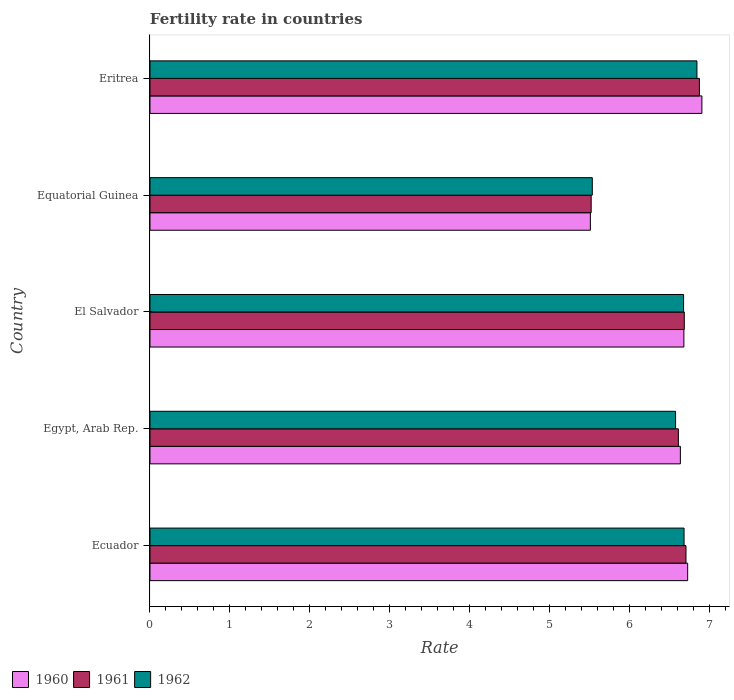How many different coloured bars are there?
Your response must be concise. 3. How many groups of bars are there?
Make the answer very short. 5. Are the number of bars on each tick of the Y-axis equal?
Keep it short and to the point. Yes. What is the label of the 4th group of bars from the top?
Give a very brief answer. Egypt, Arab Rep. What is the fertility rate in 1960 in Egypt, Arab Rep.?
Ensure brevity in your answer.  6.63. Across all countries, what is the maximum fertility rate in 1961?
Ensure brevity in your answer.  6.87. Across all countries, what is the minimum fertility rate in 1961?
Your response must be concise. 5.51. In which country was the fertility rate in 1960 maximum?
Give a very brief answer. Eritrea. In which country was the fertility rate in 1960 minimum?
Provide a succinct answer. Equatorial Guinea. What is the total fertility rate in 1960 in the graph?
Your answer should be compact. 32.43. What is the difference between the fertility rate in 1961 in El Salvador and that in Eritrea?
Your answer should be compact. -0.19. What is the difference between the fertility rate in 1960 in Eritrea and the fertility rate in 1962 in Egypt, Arab Rep.?
Give a very brief answer. 0.33. What is the average fertility rate in 1962 per country?
Offer a terse response. 6.46. What is the difference between the fertility rate in 1961 and fertility rate in 1962 in Eritrea?
Your answer should be very brief. 0.03. In how many countries, is the fertility rate in 1961 greater than 2.6 ?
Provide a succinct answer. 5. What is the ratio of the fertility rate in 1960 in Ecuador to that in Eritrea?
Provide a succinct answer. 0.97. Is the fertility rate in 1961 in Egypt, Arab Rep. less than that in Equatorial Guinea?
Ensure brevity in your answer.  No. What is the difference between the highest and the second highest fertility rate in 1960?
Provide a short and direct response. 0.18. What is the difference between the highest and the lowest fertility rate in 1961?
Offer a terse response. 1.35. In how many countries, is the fertility rate in 1962 greater than the average fertility rate in 1962 taken over all countries?
Keep it short and to the point. 4. Is the sum of the fertility rate in 1962 in Equatorial Guinea and Eritrea greater than the maximum fertility rate in 1960 across all countries?
Your answer should be very brief. Yes. What does the 3rd bar from the top in El Salvador represents?
Provide a succinct answer. 1960. Is it the case that in every country, the sum of the fertility rate in 1961 and fertility rate in 1962 is greater than the fertility rate in 1960?
Give a very brief answer. Yes. How many bars are there?
Make the answer very short. 15. Are the values on the major ticks of X-axis written in scientific E-notation?
Your response must be concise. No. Does the graph contain any zero values?
Your answer should be very brief. No. Does the graph contain grids?
Your answer should be very brief. No. Where does the legend appear in the graph?
Provide a succinct answer. Bottom left. How many legend labels are there?
Keep it short and to the point. 3. What is the title of the graph?
Provide a succinct answer. Fertility rate in countries. Does "2009" appear as one of the legend labels in the graph?
Offer a very short reply. No. What is the label or title of the X-axis?
Offer a terse response. Rate. What is the Rate in 1960 in Ecuador?
Give a very brief answer. 6.72. What is the Rate in 1962 in Ecuador?
Offer a very short reply. 6.68. What is the Rate in 1960 in Egypt, Arab Rep.?
Give a very brief answer. 6.63. What is the Rate in 1961 in Egypt, Arab Rep.?
Your answer should be very brief. 6.61. What is the Rate in 1962 in Egypt, Arab Rep.?
Make the answer very short. 6.57. What is the Rate in 1960 in El Salvador?
Offer a very short reply. 6.67. What is the Rate of 1961 in El Salvador?
Keep it short and to the point. 6.68. What is the Rate in 1962 in El Salvador?
Offer a terse response. 6.67. What is the Rate of 1960 in Equatorial Guinea?
Provide a succinct answer. 5.5. What is the Rate of 1961 in Equatorial Guinea?
Keep it short and to the point. 5.51. What is the Rate in 1962 in Equatorial Guinea?
Offer a terse response. 5.53. What is the Rate of 1960 in Eritrea?
Your answer should be compact. 6.9. What is the Rate of 1961 in Eritrea?
Ensure brevity in your answer.  6.87. What is the Rate of 1962 in Eritrea?
Provide a short and direct response. 6.84. Across all countries, what is the maximum Rate in 1960?
Offer a very short reply. 6.9. Across all countries, what is the maximum Rate in 1961?
Give a very brief answer. 6.87. Across all countries, what is the maximum Rate of 1962?
Your answer should be compact. 6.84. Across all countries, what is the minimum Rate of 1960?
Your answer should be compact. 5.5. Across all countries, what is the minimum Rate of 1961?
Keep it short and to the point. 5.51. Across all countries, what is the minimum Rate in 1962?
Offer a very short reply. 5.53. What is the total Rate of 1960 in the graph?
Offer a very short reply. 32.43. What is the total Rate in 1961 in the graph?
Provide a succinct answer. 32.37. What is the total Rate of 1962 in the graph?
Your answer should be very brief. 32.28. What is the difference between the Rate of 1960 in Ecuador and that in Egypt, Arab Rep.?
Offer a very short reply. 0.09. What is the difference between the Rate of 1961 in Ecuador and that in Egypt, Arab Rep.?
Ensure brevity in your answer.  0.1. What is the difference between the Rate of 1962 in Ecuador and that in Egypt, Arab Rep.?
Ensure brevity in your answer.  0.11. What is the difference between the Rate of 1960 in Ecuador and that in El Salvador?
Provide a succinct answer. 0.05. What is the difference between the Rate in 1961 in Ecuador and that in El Salvador?
Provide a short and direct response. 0.02. What is the difference between the Rate of 1962 in Ecuador and that in El Salvador?
Provide a short and direct response. 0.01. What is the difference between the Rate in 1960 in Ecuador and that in Equatorial Guinea?
Your answer should be very brief. 1.22. What is the difference between the Rate of 1961 in Ecuador and that in Equatorial Guinea?
Your answer should be very brief. 1.19. What is the difference between the Rate in 1962 in Ecuador and that in Equatorial Guinea?
Offer a very short reply. 1.15. What is the difference between the Rate of 1960 in Ecuador and that in Eritrea?
Offer a terse response. -0.18. What is the difference between the Rate in 1961 in Ecuador and that in Eritrea?
Make the answer very short. -0.17. What is the difference between the Rate of 1962 in Ecuador and that in Eritrea?
Keep it short and to the point. -0.16. What is the difference between the Rate of 1960 in Egypt, Arab Rep. and that in El Salvador?
Your response must be concise. -0.04. What is the difference between the Rate of 1961 in Egypt, Arab Rep. and that in El Salvador?
Make the answer very short. -0.07. What is the difference between the Rate of 1960 in Egypt, Arab Rep. and that in Equatorial Guinea?
Provide a succinct answer. 1.12. What is the difference between the Rate in 1961 in Egypt, Arab Rep. and that in Equatorial Guinea?
Give a very brief answer. 1.09. What is the difference between the Rate in 1962 in Egypt, Arab Rep. and that in Equatorial Guinea?
Keep it short and to the point. 1.04. What is the difference between the Rate in 1960 in Egypt, Arab Rep. and that in Eritrea?
Your answer should be very brief. -0.27. What is the difference between the Rate in 1961 in Egypt, Arab Rep. and that in Eritrea?
Your answer should be very brief. -0.26. What is the difference between the Rate of 1962 in Egypt, Arab Rep. and that in Eritrea?
Give a very brief answer. -0.27. What is the difference between the Rate in 1960 in El Salvador and that in Equatorial Guinea?
Offer a terse response. 1.17. What is the difference between the Rate of 1961 in El Salvador and that in Equatorial Guinea?
Ensure brevity in your answer.  1.16. What is the difference between the Rate of 1962 in El Salvador and that in Equatorial Guinea?
Make the answer very short. 1.14. What is the difference between the Rate in 1960 in El Salvador and that in Eritrea?
Provide a succinct answer. -0.23. What is the difference between the Rate of 1961 in El Salvador and that in Eritrea?
Give a very brief answer. -0.19. What is the difference between the Rate in 1962 in El Salvador and that in Eritrea?
Your answer should be very brief. -0.17. What is the difference between the Rate in 1960 in Equatorial Guinea and that in Eritrea?
Ensure brevity in your answer.  -1.39. What is the difference between the Rate of 1961 in Equatorial Guinea and that in Eritrea?
Give a very brief answer. -1.35. What is the difference between the Rate in 1962 in Equatorial Guinea and that in Eritrea?
Your answer should be compact. -1.31. What is the difference between the Rate of 1960 in Ecuador and the Rate of 1961 in Egypt, Arab Rep.?
Offer a terse response. 0.12. What is the difference between the Rate in 1960 in Ecuador and the Rate in 1962 in Egypt, Arab Rep.?
Give a very brief answer. 0.15. What is the difference between the Rate of 1961 in Ecuador and the Rate of 1962 in Egypt, Arab Rep.?
Offer a terse response. 0.13. What is the difference between the Rate in 1960 in Ecuador and the Rate in 1961 in El Salvador?
Your response must be concise. 0.04. What is the difference between the Rate in 1960 in Ecuador and the Rate in 1962 in El Salvador?
Offer a terse response. 0.05. What is the difference between the Rate of 1960 in Ecuador and the Rate of 1961 in Equatorial Guinea?
Give a very brief answer. 1.21. What is the difference between the Rate in 1960 in Ecuador and the Rate in 1962 in Equatorial Guinea?
Provide a short and direct response. 1.19. What is the difference between the Rate in 1961 in Ecuador and the Rate in 1962 in Equatorial Guinea?
Keep it short and to the point. 1.17. What is the difference between the Rate in 1960 in Ecuador and the Rate in 1961 in Eritrea?
Offer a very short reply. -0.15. What is the difference between the Rate in 1960 in Ecuador and the Rate in 1962 in Eritrea?
Offer a terse response. -0.12. What is the difference between the Rate of 1961 in Ecuador and the Rate of 1962 in Eritrea?
Your answer should be very brief. -0.14. What is the difference between the Rate of 1960 in Egypt, Arab Rep. and the Rate of 1961 in El Salvador?
Keep it short and to the point. -0.05. What is the difference between the Rate in 1960 in Egypt, Arab Rep. and the Rate in 1962 in El Salvador?
Keep it short and to the point. -0.04. What is the difference between the Rate of 1961 in Egypt, Arab Rep. and the Rate of 1962 in El Salvador?
Your answer should be very brief. -0.07. What is the difference between the Rate in 1960 in Egypt, Arab Rep. and the Rate in 1961 in Equatorial Guinea?
Your response must be concise. 1.11. What is the difference between the Rate of 1960 in Egypt, Arab Rep. and the Rate of 1962 in Equatorial Guinea?
Provide a succinct answer. 1.1. What is the difference between the Rate of 1961 in Egypt, Arab Rep. and the Rate of 1962 in Equatorial Guinea?
Keep it short and to the point. 1.08. What is the difference between the Rate of 1960 in Egypt, Arab Rep. and the Rate of 1961 in Eritrea?
Offer a very short reply. -0.24. What is the difference between the Rate of 1960 in Egypt, Arab Rep. and the Rate of 1962 in Eritrea?
Give a very brief answer. -0.21. What is the difference between the Rate of 1961 in Egypt, Arab Rep. and the Rate of 1962 in Eritrea?
Your answer should be compact. -0.23. What is the difference between the Rate in 1960 in El Salvador and the Rate in 1961 in Equatorial Guinea?
Your response must be concise. 1.16. What is the difference between the Rate in 1960 in El Salvador and the Rate in 1962 in Equatorial Guinea?
Your answer should be compact. 1.15. What is the difference between the Rate in 1961 in El Salvador and the Rate in 1962 in Equatorial Guinea?
Make the answer very short. 1.15. What is the difference between the Rate of 1960 in El Salvador and the Rate of 1961 in Eritrea?
Keep it short and to the point. -0.19. What is the difference between the Rate in 1960 in El Salvador and the Rate in 1962 in Eritrea?
Your answer should be compact. -0.16. What is the difference between the Rate of 1961 in El Salvador and the Rate of 1962 in Eritrea?
Provide a succinct answer. -0.16. What is the difference between the Rate in 1960 in Equatorial Guinea and the Rate in 1961 in Eritrea?
Provide a short and direct response. -1.36. What is the difference between the Rate of 1960 in Equatorial Guinea and the Rate of 1962 in Eritrea?
Give a very brief answer. -1.33. What is the difference between the Rate in 1961 in Equatorial Guinea and the Rate in 1962 in Eritrea?
Your response must be concise. -1.32. What is the average Rate in 1960 per country?
Your response must be concise. 6.49. What is the average Rate in 1961 per country?
Your answer should be very brief. 6.47. What is the average Rate of 1962 per country?
Ensure brevity in your answer.  6.46. What is the difference between the Rate of 1960 and Rate of 1961 in Ecuador?
Give a very brief answer. 0.02. What is the difference between the Rate in 1960 and Rate in 1962 in Ecuador?
Ensure brevity in your answer.  0.04. What is the difference between the Rate in 1961 and Rate in 1962 in Ecuador?
Provide a short and direct response. 0.02. What is the difference between the Rate of 1960 and Rate of 1961 in Egypt, Arab Rep.?
Make the answer very short. 0.03. What is the difference between the Rate of 1961 and Rate of 1962 in Egypt, Arab Rep.?
Make the answer very short. 0.04. What is the difference between the Rate of 1960 and Rate of 1961 in El Salvador?
Keep it short and to the point. -0.01. What is the difference between the Rate in 1960 and Rate in 1962 in El Salvador?
Give a very brief answer. 0. What is the difference between the Rate of 1961 and Rate of 1962 in El Salvador?
Give a very brief answer. 0.01. What is the difference between the Rate of 1960 and Rate of 1961 in Equatorial Guinea?
Your answer should be very brief. -0.01. What is the difference between the Rate of 1960 and Rate of 1962 in Equatorial Guinea?
Keep it short and to the point. -0.02. What is the difference between the Rate in 1961 and Rate in 1962 in Equatorial Guinea?
Make the answer very short. -0.01. What is the difference between the Rate in 1960 and Rate in 1961 in Eritrea?
Provide a succinct answer. 0.03. What is the difference between the Rate of 1960 and Rate of 1962 in Eritrea?
Provide a short and direct response. 0.06. What is the difference between the Rate of 1961 and Rate of 1962 in Eritrea?
Ensure brevity in your answer.  0.03. What is the ratio of the Rate in 1960 in Ecuador to that in Egypt, Arab Rep.?
Keep it short and to the point. 1.01. What is the ratio of the Rate of 1961 in Ecuador to that in Egypt, Arab Rep.?
Keep it short and to the point. 1.01. What is the ratio of the Rate in 1962 in Ecuador to that in Egypt, Arab Rep.?
Offer a terse response. 1.02. What is the ratio of the Rate of 1960 in Ecuador to that in El Salvador?
Offer a very short reply. 1.01. What is the ratio of the Rate of 1961 in Ecuador to that in El Salvador?
Provide a succinct answer. 1. What is the ratio of the Rate of 1962 in Ecuador to that in El Salvador?
Offer a very short reply. 1. What is the ratio of the Rate of 1960 in Ecuador to that in Equatorial Guinea?
Ensure brevity in your answer.  1.22. What is the ratio of the Rate in 1961 in Ecuador to that in Equatorial Guinea?
Give a very brief answer. 1.21. What is the ratio of the Rate of 1962 in Ecuador to that in Equatorial Guinea?
Keep it short and to the point. 1.21. What is the ratio of the Rate in 1960 in Ecuador to that in Eritrea?
Ensure brevity in your answer.  0.97. What is the ratio of the Rate of 1961 in Ecuador to that in Eritrea?
Your response must be concise. 0.98. What is the ratio of the Rate in 1962 in Ecuador to that in Eritrea?
Ensure brevity in your answer.  0.98. What is the ratio of the Rate of 1960 in Egypt, Arab Rep. to that in El Salvador?
Offer a terse response. 0.99. What is the ratio of the Rate of 1961 in Egypt, Arab Rep. to that in El Salvador?
Provide a short and direct response. 0.99. What is the ratio of the Rate in 1962 in Egypt, Arab Rep. to that in El Salvador?
Offer a terse response. 0.98. What is the ratio of the Rate of 1960 in Egypt, Arab Rep. to that in Equatorial Guinea?
Your response must be concise. 1.2. What is the ratio of the Rate in 1961 in Egypt, Arab Rep. to that in Equatorial Guinea?
Provide a short and direct response. 1.2. What is the ratio of the Rate in 1962 in Egypt, Arab Rep. to that in Equatorial Guinea?
Your response must be concise. 1.19. What is the ratio of the Rate of 1961 in Egypt, Arab Rep. to that in Eritrea?
Your answer should be compact. 0.96. What is the ratio of the Rate in 1962 in Egypt, Arab Rep. to that in Eritrea?
Your answer should be compact. 0.96. What is the ratio of the Rate of 1960 in El Salvador to that in Equatorial Guinea?
Offer a terse response. 1.21. What is the ratio of the Rate in 1961 in El Salvador to that in Equatorial Guinea?
Offer a terse response. 1.21. What is the ratio of the Rate of 1962 in El Salvador to that in Equatorial Guinea?
Your response must be concise. 1.21. What is the ratio of the Rate in 1960 in El Salvador to that in Eritrea?
Your response must be concise. 0.97. What is the ratio of the Rate of 1961 in El Salvador to that in Eritrea?
Your response must be concise. 0.97. What is the ratio of the Rate in 1962 in El Salvador to that in Eritrea?
Provide a short and direct response. 0.98. What is the ratio of the Rate of 1960 in Equatorial Guinea to that in Eritrea?
Offer a very short reply. 0.8. What is the ratio of the Rate of 1961 in Equatorial Guinea to that in Eritrea?
Your answer should be very brief. 0.8. What is the ratio of the Rate in 1962 in Equatorial Guinea to that in Eritrea?
Make the answer very short. 0.81. What is the difference between the highest and the second highest Rate in 1960?
Your answer should be compact. 0.18. What is the difference between the highest and the second highest Rate in 1961?
Offer a terse response. 0.17. What is the difference between the highest and the second highest Rate in 1962?
Provide a succinct answer. 0.16. What is the difference between the highest and the lowest Rate of 1960?
Give a very brief answer. 1.39. What is the difference between the highest and the lowest Rate of 1961?
Make the answer very short. 1.35. What is the difference between the highest and the lowest Rate in 1962?
Your response must be concise. 1.31. 